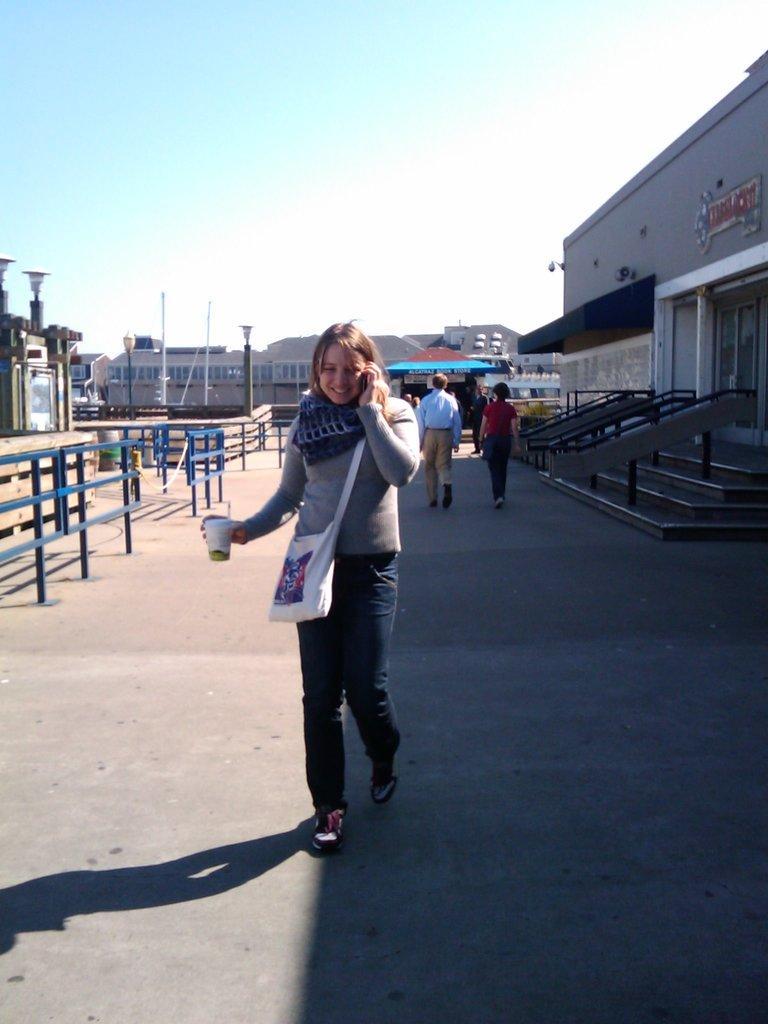Describe this image in one or two sentences. In this image we can see the railing, fence, people, stairs, buildings, light poles and in the background we can see the sky. 